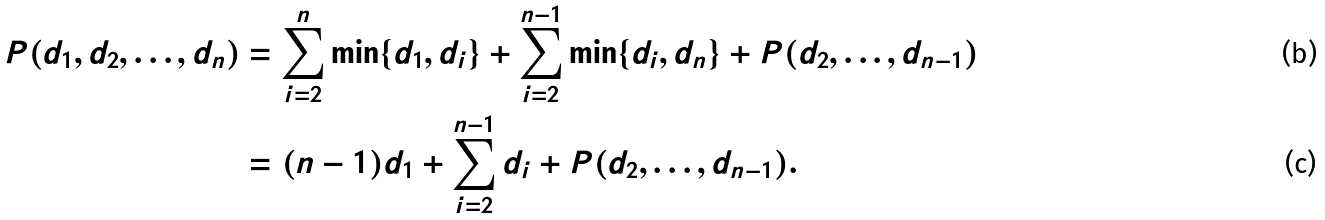Convert formula to latex. <formula><loc_0><loc_0><loc_500><loc_500>P ( d _ { 1 } , d _ { 2 } , \dots , d _ { n } ) & = \sum _ { i = 2 } ^ { n } \min \{ d _ { 1 } , d _ { i } \} + \sum _ { i = 2 } ^ { n - 1 } \min \{ d _ { i } , d _ { n } \} + P ( d _ { 2 } , \dots , d _ { n - 1 } ) \\ & = ( n - 1 ) d _ { 1 } + \sum _ { i = 2 } ^ { n - 1 } d _ { i } + P ( d _ { 2 } , \dots , d _ { n - 1 } ) .</formula> 